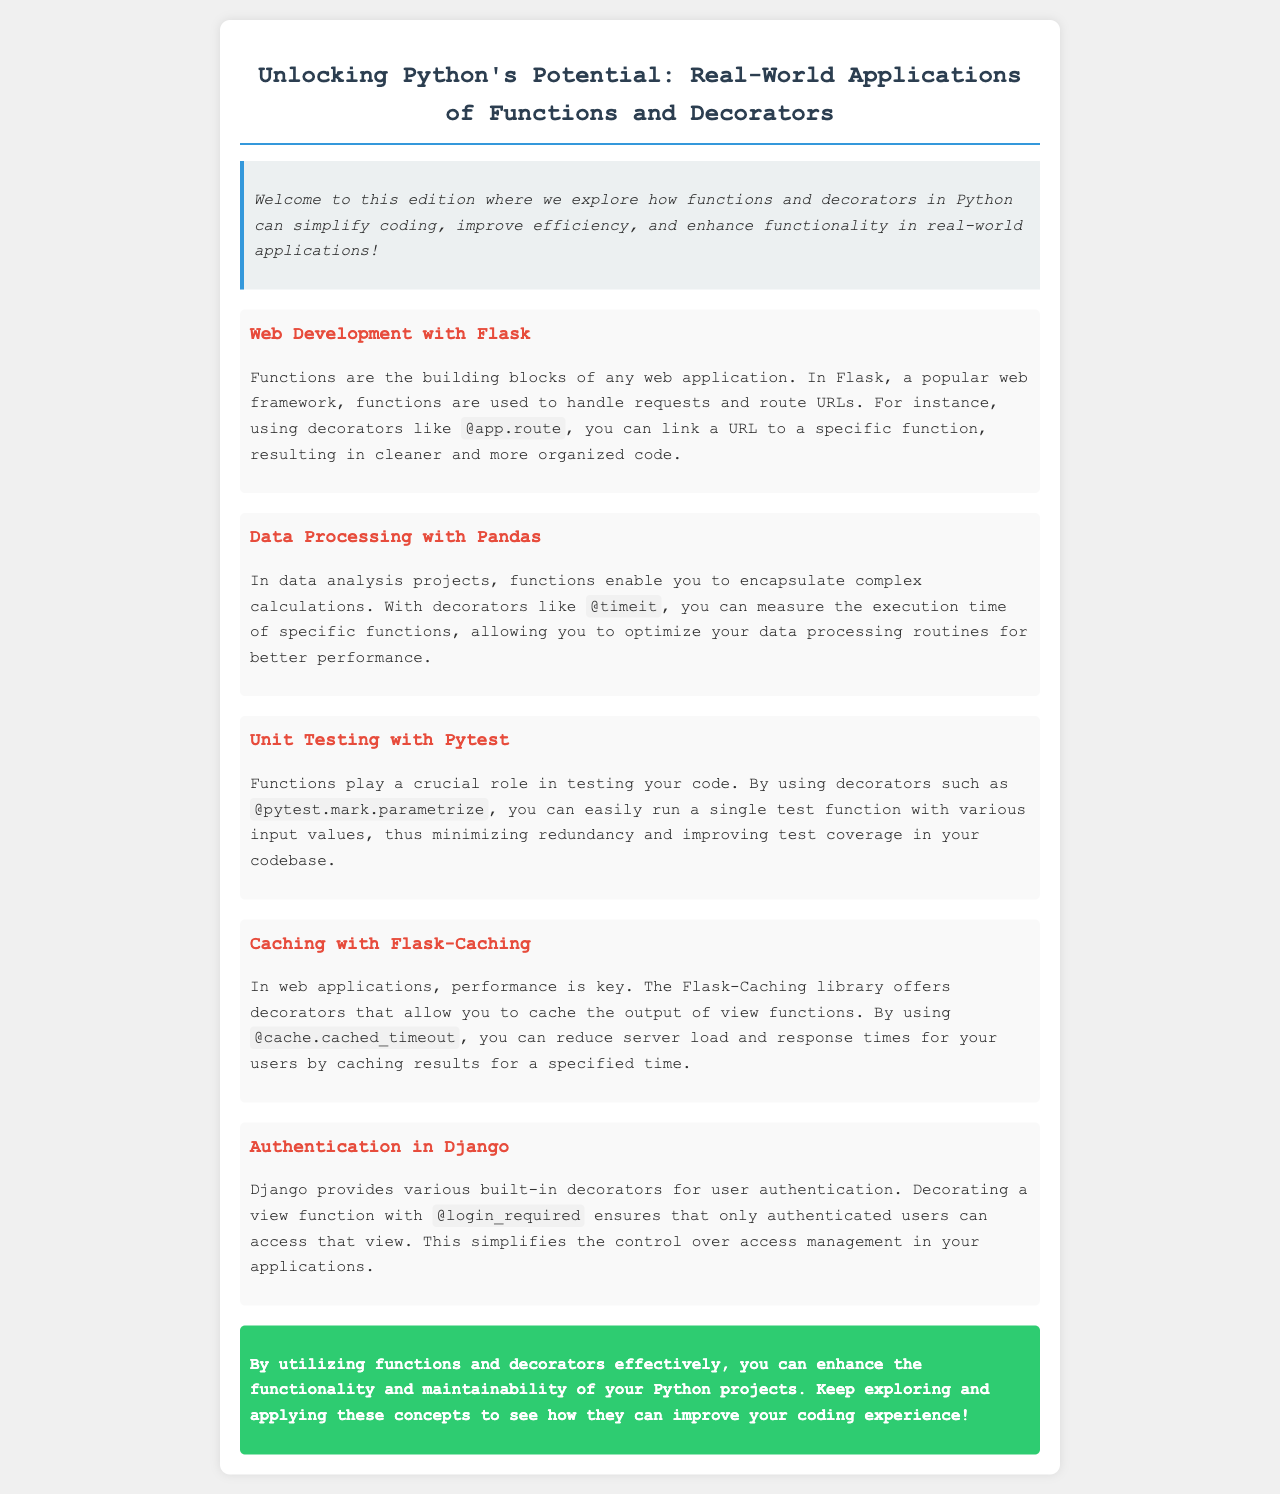What is the title of the newsletter? The title of the newsletter is clearly stated in the document as "Unlocking Python's Potential: Real-World Applications of Functions and Decorators."
Answer: Unlocking Python's Potential: Real-World Applications of Functions and Decorators Which web framework is mentioned for its use of functions? The document references a popular web framework that uses functions for handling requests and routing URLs, specifically noting Flask.
Answer: Flask What type of decorator is used to measure execution time? The newsletter discusses a specific decorator that helps in measuring execution time in data processing, which is referred to as @timeit.
Answer: @timeit How does Flask-Caching improve performance? The document explains that Flask-Caching improves performance by using a particular decorator to cache outputs, which is @cache.cached_timeout.
Answer: @cache.cached_timeout What decorator ensures that only authenticated users can access a view in Django? The text states that Django uses a specific decorator to manage user authentication on views, which is identified as @login_required.
Answer: @login_required How many real-world applications are showcased in the document? The document lists five unique applications demonstrating functions and decorators in Python, each with its description.
Answer: Five What color is used for the conclusion section? The conclusion section has a defined background color which is specified as green.
Answer: Green 